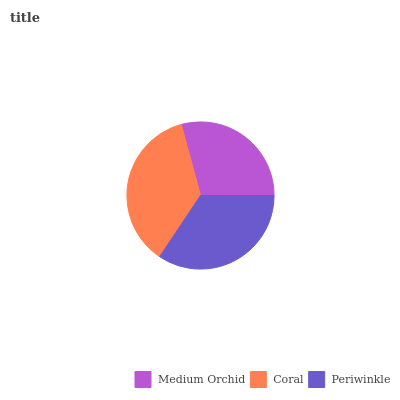Is Medium Orchid the minimum?
Answer yes or no. Yes. Is Coral the maximum?
Answer yes or no. Yes. Is Periwinkle the minimum?
Answer yes or no. No. Is Periwinkle the maximum?
Answer yes or no. No. Is Coral greater than Periwinkle?
Answer yes or no. Yes. Is Periwinkle less than Coral?
Answer yes or no. Yes. Is Periwinkle greater than Coral?
Answer yes or no. No. Is Coral less than Periwinkle?
Answer yes or no. No. Is Periwinkle the high median?
Answer yes or no. Yes. Is Periwinkle the low median?
Answer yes or no. Yes. Is Medium Orchid the high median?
Answer yes or no. No. Is Coral the low median?
Answer yes or no. No. 